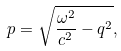Convert formula to latex. <formula><loc_0><loc_0><loc_500><loc_500>p = \sqrt { \frac { \omega ^ { 2 } } { c ^ { 2 } } - q ^ { 2 } } ,</formula> 